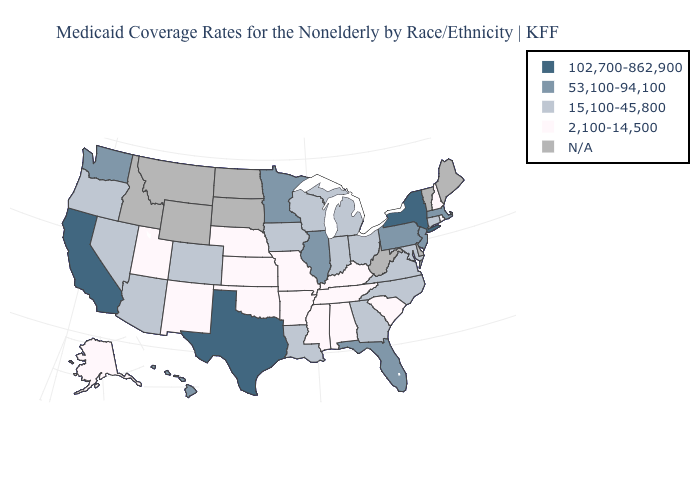What is the value of Vermont?
Quick response, please. N/A. Does the first symbol in the legend represent the smallest category?
Be succinct. No. Name the states that have a value in the range N/A?
Concise answer only. Delaware, Idaho, Maine, Montana, North Dakota, South Dakota, Vermont, West Virginia, Wyoming. What is the value of Wyoming?
Short answer required. N/A. Does the first symbol in the legend represent the smallest category?
Be succinct. No. Does the map have missing data?
Be succinct. Yes. Is the legend a continuous bar?
Quick response, please. No. What is the lowest value in states that border Alabama?
Be succinct. 2,100-14,500. What is the value of Oklahoma?
Short answer required. 2,100-14,500. What is the value of South Carolina?
Answer briefly. 2,100-14,500. Which states have the lowest value in the Northeast?
Give a very brief answer. New Hampshire, Rhode Island. Name the states that have a value in the range 2,100-14,500?
Short answer required. Alabama, Alaska, Arkansas, Kansas, Kentucky, Mississippi, Missouri, Nebraska, New Hampshire, New Mexico, Oklahoma, Rhode Island, South Carolina, Tennessee, Utah. How many symbols are there in the legend?
Concise answer only. 5. 